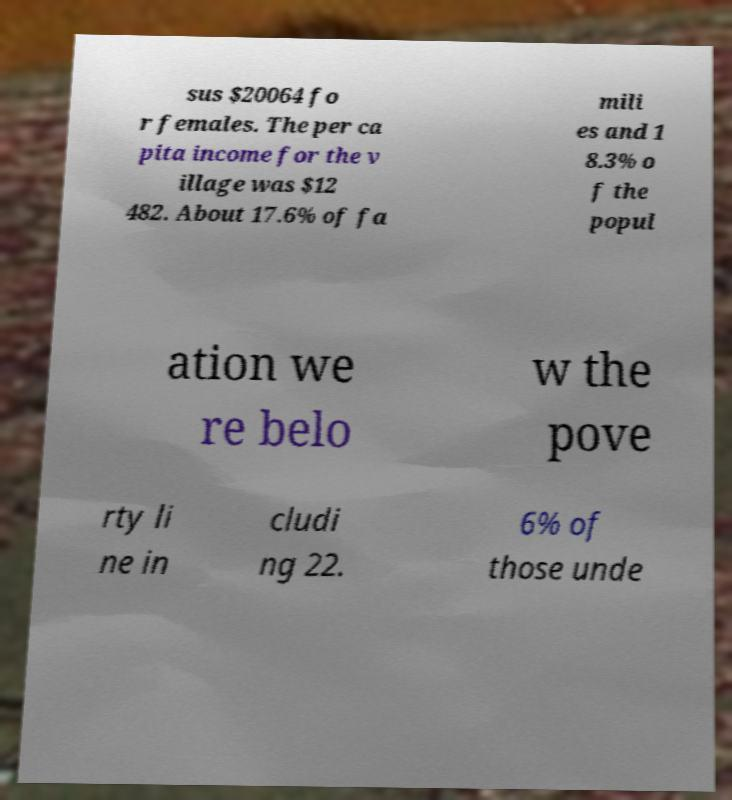Could you assist in decoding the text presented in this image and type it out clearly? sus $20064 fo r females. The per ca pita income for the v illage was $12 482. About 17.6% of fa mili es and 1 8.3% o f the popul ation we re belo w the pove rty li ne in cludi ng 22. 6% of those unde 